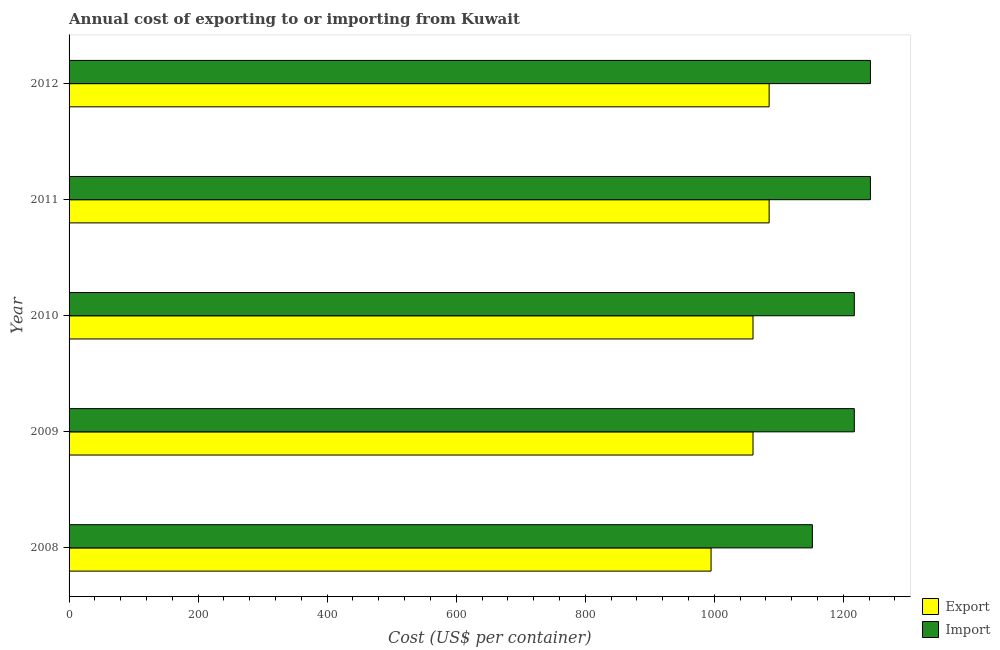How many groups of bars are there?
Provide a succinct answer. 5. How many bars are there on the 1st tick from the top?
Provide a short and direct response. 2. What is the import cost in 2011?
Ensure brevity in your answer.  1242. Across all years, what is the maximum import cost?
Give a very brief answer. 1242. Across all years, what is the minimum export cost?
Offer a very short reply. 995. In which year was the export cost maximum?
Your response must be concise. 2011. In which year was the import cost minimum?
Your answer should be very brief. 2008. What is the total export cost in the graph?
Your response must be concise. 5285. What is the difference between the export cost in 2008 and that in 2009?
Provide a short and direct response. -65. What is the difference between the export cost in 2008 and the import cost in 2009?
Keep it short and to the point. -222. What is the average export cost per year?
Provide a succinct answer. 1057. In the year 2010, what is the difference between the import cost and export cost?
Make the answer very short. 157. In how many years, is the import cost greater than 1040 US$?
Your answer should be very brief. 5. What is the ratio of the import cost in 2009 to that in 2010?
Offer a very short reply. 1. Is the difference between the import cost in 2008 and 2009 greater than the difference between the export cost in 2008 and 2009?
Offer a terse response. No. What is the difference between the highest and the lowest import cost?
Ensure brevity in your answer.  90. In how many years, is the export cost greater than the average export cost taken over all years?
Your answer should be very brief. 4. What does the 1st bar from the top in 2008 represents?
Provide a succinct answer. Import. What does the 1st bar from the bottom in 2010 represents?
Keep it short and to the point. Export. How many bars are there?
Your answer should be compact. 10. Are all the bars in the graph horizontal?
Provide a short and direct response. Yes. How many years are there in the graph?
Keep it short and to the point. 5. What is the difference between two consecutive major ticks on the X-axis?
Your answer should be compact. 200. Are the values on the major ticks of X-axis written in scientific E-notation?
Offer a terse response. No. How are the legend labels stacked?
Keep it short and to the point. Vertical. What is the title of the graph?
Provide a succinct answer. Annual cost of exporting to or importing from Kuwait. What is the label or title of the X-axis?
Offer a terse response. Cost (US$ per container). What is the label or title of the Y-axis?
Offer a terse response. Year. What is the Cost (US$ per container) of Export in 2008?
Keep it short and to the point. 995. What is the Cost (US$ per container) in Import in 2008?
Offer a terse response. 1152. What is the Cost (US$ per container) of Export in 2009?
Offer a terse response. 1060. What is the Cost (US$ per container) of Import in 2009?
Make the answer very short. 1217. What is the Cost (US$ per container) of Export in 2010?
Your response must be concise. 1060. What is the Cost (US$ per container) of Import in 2010?
Your response must be concise. 1217. What is the Cost (US$ per container) of Export in 2011?
Give a very brief answer. 1085. What is the Cost (US$ per container) in Import in 2011?
Ensure brevity in your answer.  1242. What is the Cost (US$ per container) of Export in 2012?
Your response must be concise. 1085. What is the Cost (US$ per container) in Import in 2012?
Offer a very short reply. 1242. Across all years, what is the maximum Cost (US$ per container) of Export?
Make the answer very short. 1085. Across all years, what is the maximum Cost (US$ per container) in Import?
Give a very brief answer. 1242. Across all years, what is the minimum Cost (US$ per container) in Export?
Provide a succinct answer. 995. Across all years, what is the minimum Cost (US$ per container) of Import?
Give a very brief answer. 1152. What is the total Cost (US$ per container) of Export in the graph?
Make the answer very short. 5285. What is the total Cost (US$ per container) of Import in the graph?
Make the answer very short. 6070. What is the difference between the Cost (US$ per container) in Export in 2008 and that in 2009?
Make the answer very short. -65. What is the difference between the Cost (US$ per container) in Import in 2008 and that in 2009?
Provide a short and direct response. -65. What is the difference between the Cost (US$ per container) in Export in 2008 and that in 2010?
Your answer should be compact. -65. What is the difference between the Cost (US$ per container) of Import in 2008 and that in 2010?
Provide a short and direct response. -65. What is the difference between the Cost (US$ per container) of Export in 2008 and that in 2011?
Your answer should be compact. -90. What is the difference between the Cost (US$ per container) in Import in 2008 and that in 2011?
Ensure brevity in your answer.  -90. What is the difference between the Cost (US$ per container) in Export in 2008 and that in 2012?
Provide a short and direct response. -90. What is the difference between the Cost (US$ per container) in Import in 2008 and that in 2012?
Offer a terse response. -90. What is the difference between the Cost (US$ per container) in Export in 2009 and that in 2011?
Make the answer very short. -25. What is the difference between the Cost (US$ per container) in Export in 2010 and that in 2012?
Your answer should be compact. -25. What is the difference between the Cost (US$ per container) of Export in 2011 and that in 2012?
Provide a short and direct response. 0. What is the difference between the Cost (US$ per container) of Import in 2011 and that in 2012?
Give a very brief answer. 0. What is the difference between the Cost (US$ per container) in Export in 2008 and the Cost (US$ per container) in Import in 2009?
Provide a short and direct response. -222. What is the difference between the Cost (US$ per container) of Export in 2008 and the Cost (US$ per container) of Import in 2010?
Provide a succinct answer. -222. What is the difference between the Cost (US$ per container) of Export in 2008 and the Cost (US$ per container) of Import in 2011?
Give a very brief answer. -247. What is the difference between the Cost (US$ per container) of Export in 2008 and the Cost (US$ per container) of Import in 2012?
Your answer should be compact. -247. What is the difference between the Cost (US$ per container) of Export in 2009 and the Cost (US$ per container) of Import in 2010?
Give a very brief answer. -157. What is the difference between the Cost (US$ per container) in Export in 2009 and the Cost (US$ per container) in Import in 2011?
Provide a succinct answer. -182. What is the difference between the Cost (US$ per container) of Export in 2009 and the Cost (US$ per container) of Import in 2012?
Your response must be concise. -182. What is the difference between the Cost (US$ per container) in Export in 2010 and the Cost (US$ per container) in Import in 2011?
Provide a succinct answer. -182. What is the difference between the Cost (US$ per container) in Export in 2010 and the Cost (US$ per container) in Import in 2012?
Offer a terse response. -182. What is the difference between the Cost (US$ per container) in Export in 2011 and the Cost (US$ per container) in Import in 2012?
Give a very brief answer. -157. What is the average Cost (US$ per container) of Export per year?
Offer a very short reply. 1057. What is the average Cost (US$ per container) in Import per year?
Provide a short and direct response. 1214. In the year 2008, what is the difference between the Cost (US$ per container) in Export and Cost (US$ per container) in Import?
Keep it short and to the point. -157. In the year 2009, what is the difference between the Cost (US$ per container) in Export and Cost (US$ per container) in Import?
Provide a short and direct response. -157. In the year 2010, what is the difference between the Cost (US$ per container) in Export and Cost (US$ per container) in Import?
Offer a very short reply. -157. In the year 2011, what is the difference between the Cost (US$ per container) in Export and Cost (US$ per container) in Import?
Ensure brevity in your answer.  -157. In the year 2012, what is the difference between the Cost (US$ per container) in Export and Cost (US$ per container) in Import?
Provide a succinct answer. -157. What is the ratio of the Cost (US$ per container) of Export in 2008 to that in 2009?
Your answer should be compact. 0.94. What is the ratio of the Cost (US$ per container) in Import in 2008 to that in 2009?
Keep it short and to the point. 0.95. What is the ratio of the Cost (US$ per container) of Export in 2008 to that in 2010?
Your answer should be compact. 0.94. What is the ratio of the Cost (US$ per container) in Import in 2008 to that in 2010?
Provide a succinct answer. 0.95. What is the ratio of the Cost (US$ per container) of Export in 2008 to that in 2011?
Your answer should be compact. 0.92. What is the ratio of the Cost (US$ per container) in Import in 2008 to that in 2011?
Your answer should be very brief. 0.93. What is the ratio of the Cost (US$ per container) of Export in 2008 to that in 2012?
Keep it short and to the point. 0.92. What is the ratio of the Cost (US$ per container) in Import in 2008 to that in 2012?
Ensure brevity in your answer.  0.93. What is the ratio of the Cost (US$ per container) in Import in 2009 to that in 2010?
Offer a terse response. 1. What is the ratio of the Cost (US$ per container) in Export in 2009 to that in 2011?
Your response must be concise. 0.98. What is the ratio of the Cost (US$ per container) in Import in 2009 to that in 2011?
Your answer should be compact. 0.98. What is the ratio of the Cost (US$ per container) of Export in 2009 to that in 2012?
Provide a succinct answer. 0.98. What is the ratio of the Cost (US$ per container) of Import in 2009 to that in 2012?
Offer a very short reply. 0.98. What is the ratio of the Cost (US$ per container) of Import in 2010 to that in 2011?
Your response must be concise. 0.98. What is the ratio of the Cost (US$ per container) of Export in 2010 to that in 2012?
Provide a succinct answer. 0.98. What is the ratio of the Cost (US$ per container) of Import in 2010 to that in 2012?
Provide a short and direct response. 0.98. What is the difference between the highest and the second highest Cost (US$ per container) of Export?
Ensure brevity in your answer.  0. What is the difference between the highest and the second highest Cost (US$ per container) of Import?
Ensure brevity in your answer.  0. 